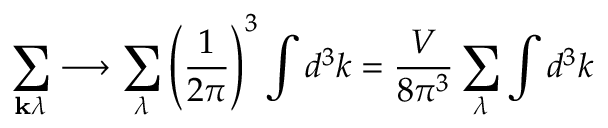Convert formula to latex. <formula><loc_0><loc_0><loc_500><loc_500>\sum _ { k \lambda } \longrightarrow \sum _ { \lambda } \left ( { \frac { 1 } { 2 \pi } } \right ) ^ { 3 } \int d ^ { 3 } k = { \frac { V } { 8 \pi ^ { 3 } } } \sum _ { \lambda } \int d ^ { 3 } k</formula> 